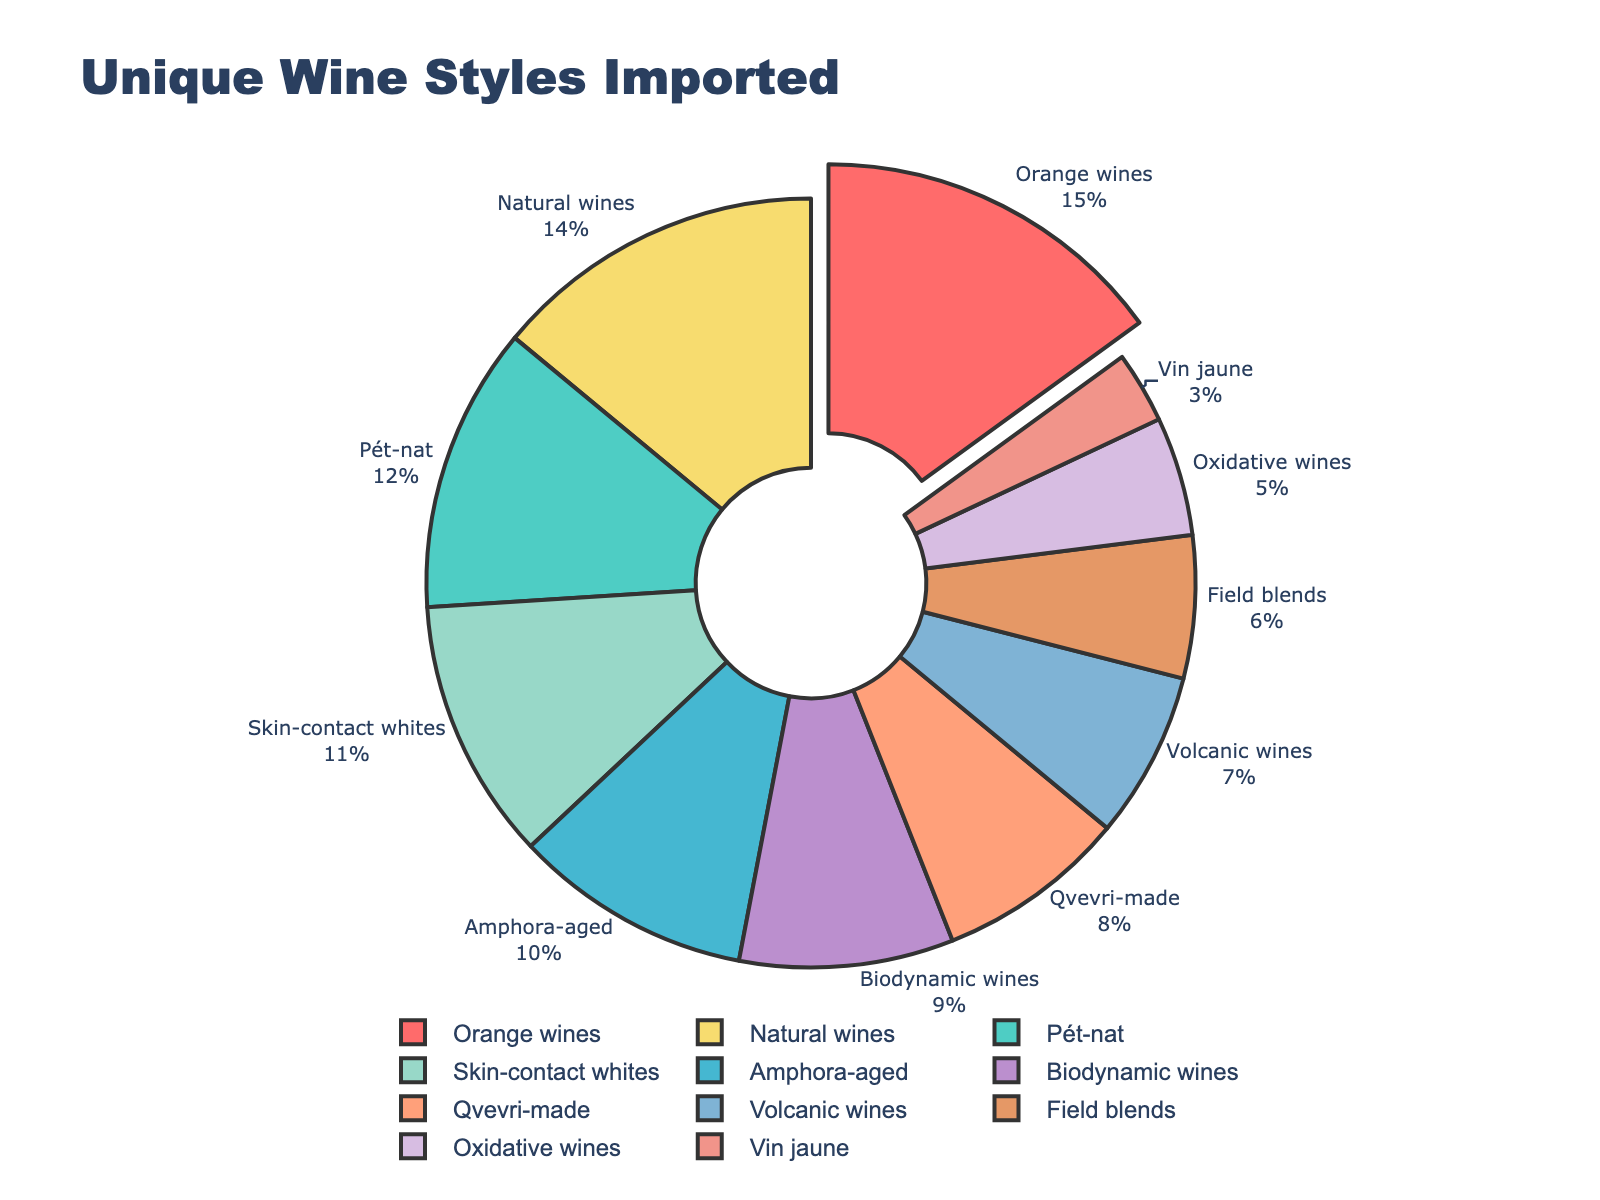What wine style has the highest percentage? By observing the pie chart, we can see which segment is the largest and pulled out slightly, indicating it is the highest. This corresponds to "Orange wines" with a percentage of 15%.
Answer: Orange wines What is the combined percentage of Pét-nat and Natural wines? To find the combined percentage, we simply add the percentages of Pét-nat (12%) and Natural wines (14%). 12 + 14 = 26
Answer: 26 Which wine style has the smallest percentage? The smallest segment in the pie chart corresponds to "Vin jaune" which is 3%.
Answer: Vin jaune By how much does the percentage of Orange wines exceed Biodynamic wines? We subtract the percentage of Biodynamic wines (9%) from the percentage of Orange wines (15%). 15 - 9 = 6
Answer: 6 Are there more percentage points of Amphora-aged wines or Skin-contact whites? By looking at the pie chart, we see Amphora-aged wines have 10% while Skin-contact whites have 11%. Therefore, Skin-contact whites have a higher percentage.
Answer: Skin-contact whites What is the total percentage of all wine styles with less than 10% each? Identify and sum the percentages of wine styles below 10%: Amphora-aged (10%), Qvevri-made (8%), Biodynamic (9%), Volcanic (7%), Field blends (6%), Oxidative (5%), Vin jaune (3%). Exclude Amphora-aged. 8 + 9 + 7 + 6 + 5 + 3 = 38
Answer: 38 Which wine style has a percentage closest to 10%? Looking at the pie chart, the wine style with a percentage closest to 10% is Amphora-aged with exactly 10%.
Answer: Amphora-aged What is the average percentage of Natural wines, Biodynamic wines, and Volcanic wines? Calculate the sum of percentages of the three wine styles and divide by their count. Natural wines (14%) + Biodynamic wines (9%) + Volcanic wines (7%) = 14 + 9 + 7 = 30. Then divide by 3. 30 / 3 = 10
Answer: 10 Which color segment represents Oxidative wines? By observing the colors in the pie chart, Oxidative wines are represented by the segment in a lighter red color.
Answer: Lighter red 